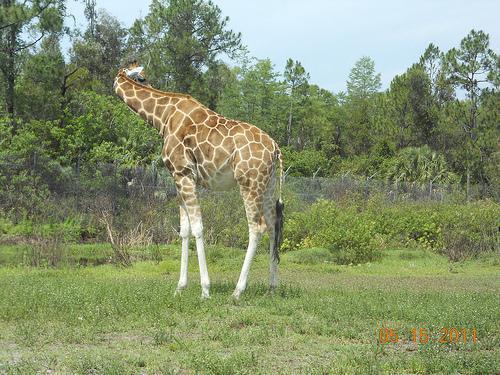How many giraffes are in the picture?
Give a very brief answer. 1. 